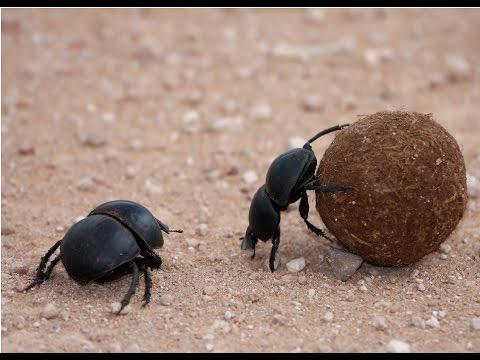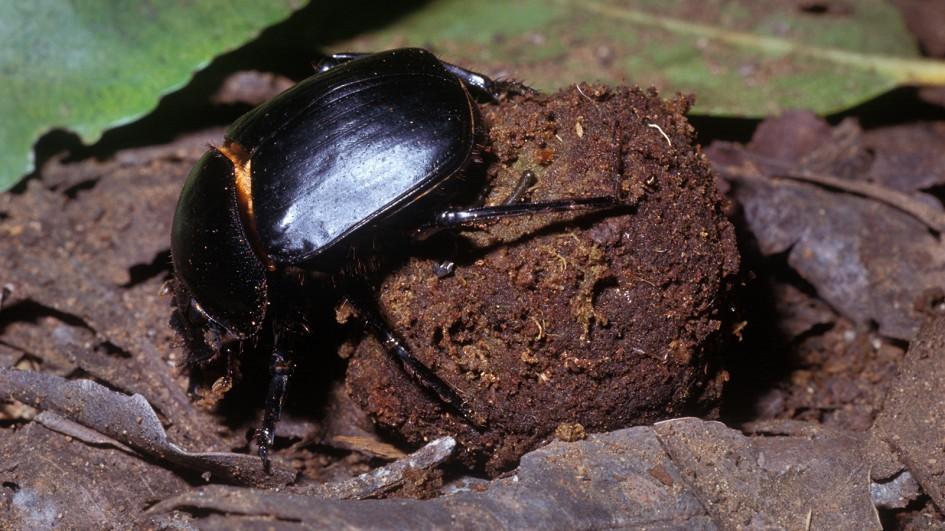The first image is the image on the left, the second image is the image on the right. For the images shown, is this caption "The image on the left shows two beetles on top of a dungball." true? Answer yes or no. No. 